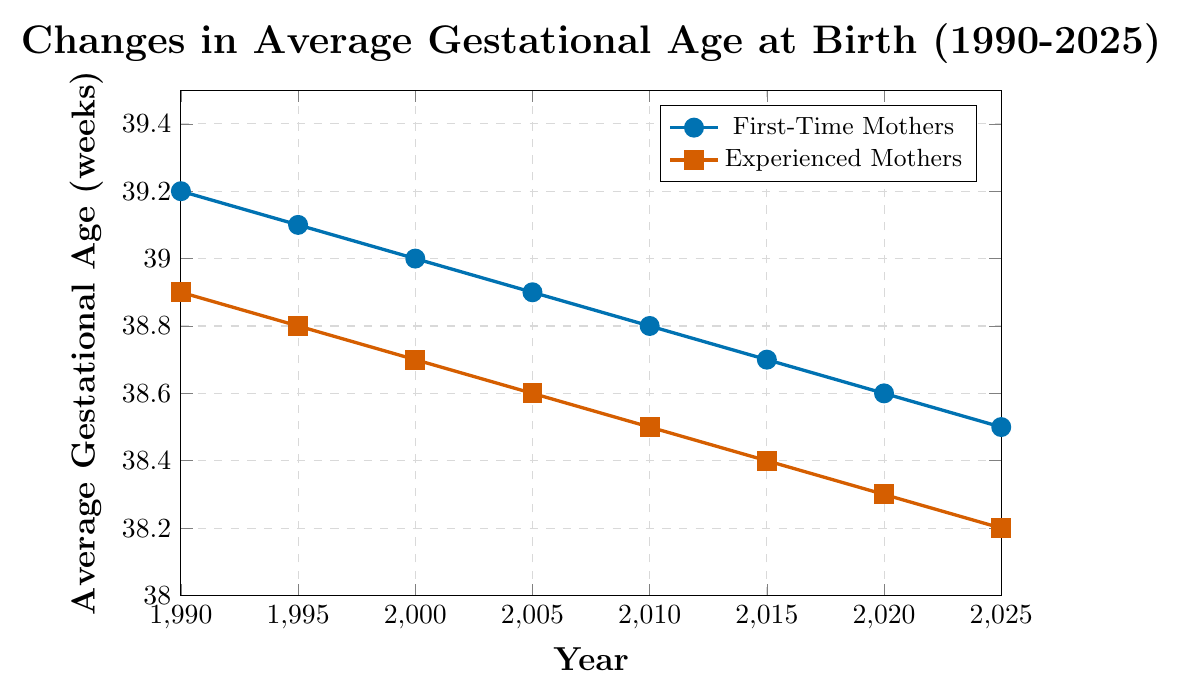What is the average gestational age at birth for first-time mothers in 1990? The plot shows the gestational age in weeks on the y-axis, and the year on the x-axis. For first-time mothers in 1990, the plot shows 39.2 weeks.
Answer: 39.2 weeks What is the trend in average gestational age for experienced mothers from 1990 to 2025? Observing the plot, the line representing experienced mothers' gestational age consistently decreases from 38.9 weeks in 1990 to 38.2 weeks in 2025.
Answer: Decreasing By how much did the average gestational age for first-time mothers decrease from 1990 to 2025? The gestational age for first-time mothers in 1990 is 39.2 weeks and in 2025 is 38.5 weeks. The difference is 39.2 - 38.5 = 0.7 weeks.
Answer: 0.7 weeks Which group, first-time mothers or experienced mothers, had a lower gestational age in 2000? Comparing the y-values (gestational age) for 2000, first-time mothers had 39.0 weeks and experienced mothers had 38.7 weeks. Experienced mothers had a lower gestational age.
Answer: Experienced mothers What is the average gestational age for experienced mothers over the years 1990, 2000, 2010, and 2020? Sum of gestational ages for experienced mothers in the mentioned years: 38.9 + 38.7 + 38.5 + 38.3 = 154.4 weeks. Average is 154.4 / 4 = 38.6 weeks.
Answer: 38.6 weeks In which year did both first-time and experienced mothers show the same rate of decrease in gestational age compared to the previous year? Since this requires comparing years: from 1990 to 1995, first-time mothers decreased by 0.1 weeks (39.2 to 39.1) and experienced mothers by 0.1 weeks (38.9 to 38.8). Year 1995 shows the same rate of decrease.
Answer: 1995 Which group had a steeper decline in average gestational age from 1990 to 2025? Calculating slopes for both groups: First-time mothers: (38.5 - 39.2) / (2025 - 1990) = -0.7 / 35 = -0.02 weeks/year. Experienced mothers: (38.2 - 38.9) / (2025 - 1990) = -0.7 / 35 = -0.02 weeks/year. They had the same steepness.
Answer: Same What is the approximate difference in gestational age between first-time and experienced mothers in the year 2015? For the year 2015, first-time mothers had 38.7 weeks and experienced mothers had 38.4 weeks. The difference is 38.7 - 38.4 = 0.3 weeks.
Answer: 0.3 weeks 